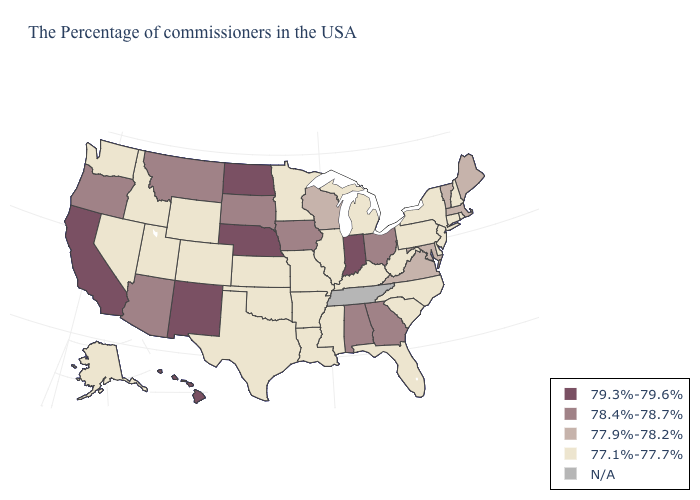What is the value of Massachusetts?
Be succinct. 77.9%-78.2%. Name the states that have a value in the range 77.9%-78.2%?
Give a very brief answer. Maine, Massachusetts, Vermont, Maryland, Virginia, Wisconsin. Name the states that have a value in the range 78.4%-78.7%?
Write a very short answer. Ohio, Georgia, Alabama, Iowa, South Dakota, Montana, Arizona, Oregon. Name the states that have a value in the range 78.4%-78.7%?
Keep it brief. Ohio, Georgia, Alabama, Iowa, South Dakota, Montana, Arizona, Oregon. Does Georgia have the highest value in the South?
Short answer required. Yes. What is the lowest value in the South?
Keep it brief. 77.1%-77.7%. What is the value of Louisiana?
Give a very brief answer. 77.1%-77.7%. Name the states that have a value in the range 77.9%-78.2%?
Be succinct. Maine, Massachusetts, Vermont, Maryland, Virginia, Wisconsin. What is the value of North Dakota?
Write a very short answer. 79.3%-79.6%. Name the states that have a value in the range N/A?
Answer briefly. Tennessee. What is the value of Virginia?
Give a very brief answer. 77.9%-78.2%. Does the first symbol in the legend represent the smallest category?
Keep it brief. No. Is the legend a continuous bar?
Give a very brief answer. No. Name the states that have a value in the range 78.4%-78.7%?
Give a very brief answer. Ohio, Georgia, Alabama, Iowa, South Dakota, Montana, Arizona, Oregon. Does West Virginia have the lowest value in the South?
Short answer required. Yes. 